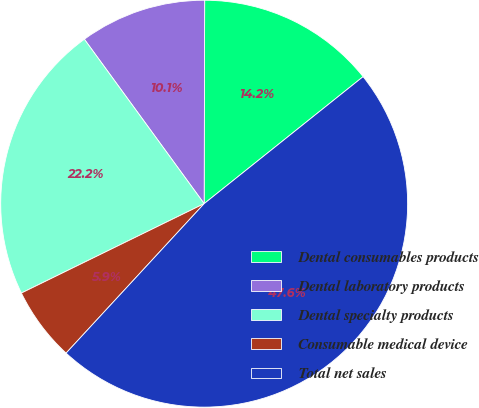<chart> <loc_0><loc_0><loc_500><loc_500><pie_chart><fcel>Dental consumables products<fcel>Dental laboratory products<fcel>Dental specialty products<fcel>Consumable medical device<fcel>Total net sales<nl><fcel>14.23%<fcel>10.06%<fcel>22.22%<fcel>5.89%<fcel>47.6%<nl></chart> 